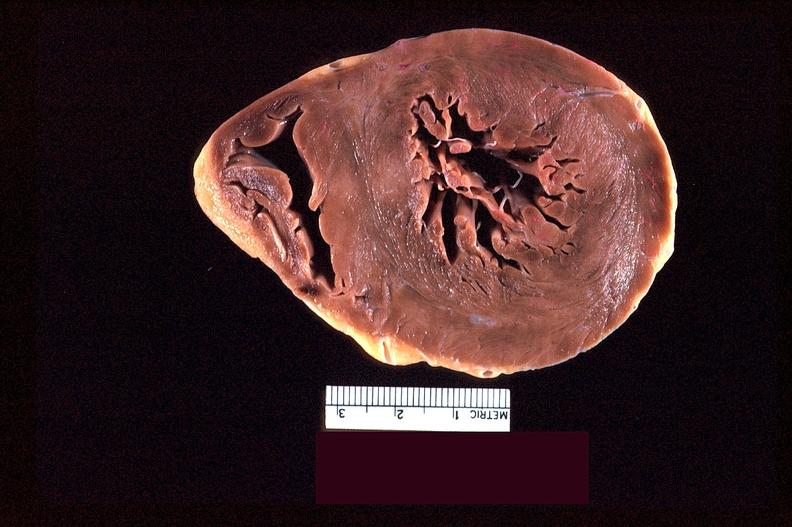s marfans syndrome present?
Answer the question using a single word or phrase. No 